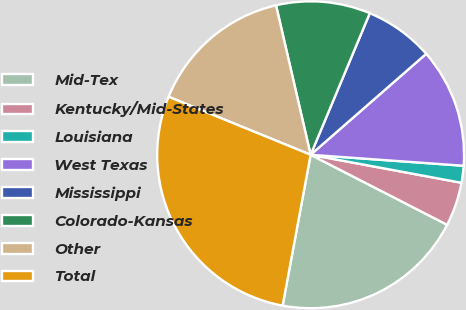Convert chart. <chart><loc_0><loc_0><loc_500><loc_500><pie_chart><fcel>Mid-Tex<fcel>Kentucky/Mid-States<fcel>Louisiana<fcel>West Texas<fcel>Mississippi<fcel>Colorado-Kansas<fcel>Other<fcel>Total<nl><fcel>20.38%<fcel>4.62%<fcel>1.78%<fcel>12.57%<fcel>7.27%<fcel>9.92%<fcel>15.21%<fcel>28.25%<nl></chart> 